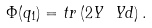Convert formula to latex. <formula><loc_0><loc_0><loc_500><loc_500>\Phi ( q _ { 1 } ) = t r \left ( 2 Y \ Y d \right ) .</formula> 